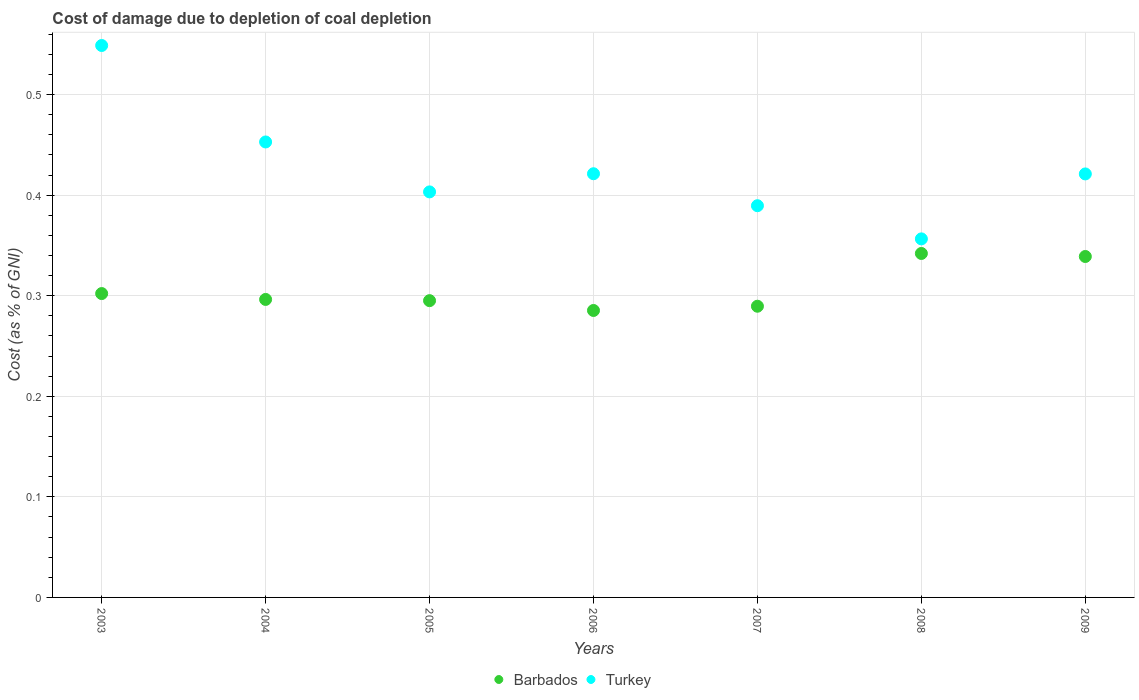How many different coloured dotlines are there?
Your answer should be compact. 2. What is the cost of damage caused due to coal depletion in Turkey in 2007?
Your response must be concise. 0.39. Across all years, what is the maximum cost of damage caused due to coal depletion in Barbados?
Offer a terse response. 0.34. Across all years, what is the minimum cost of damage caused due to coal depletion in Barbados?
Your answer should be compact. 0.29. In which year was the cost of damage caused due to coal depletion in Barbados maximum?
Your answer should be very brief. 2008. What is the total cost of damage caused due to coal depletion in Barbados in the graph?
Give a very brief answer. 2.15. What is the difference between the cost of damage caused due to coal depletion in Barbados in 2006 and that in 2007?
Offer a terse response. -0. What is the difference between the cost of damage caused due to coal depletion in Barbados in 2006 and the cost of damage caused due to coal depletion in Turkey in 2004?
Make the answer very short. -0.17. What is the average cost of damage caused due to coal depletion in Turkey per year?
Provide a succinct answer. 0.43. In the year 2009, what is the difference between the cost of damage caused due to coal depletion in Turkey and cost of damage caused due to coal depletion in Barbados?
Offer a terse response. 0.08. What is the ratio of the cost of damage caused due to coal depletion in Turkey in 2007 to that in 2008?
Your response must be concise. 1.09. Is the difference between the cost of damage caused due to coal depletion in Turkey in 2004 and 2006 greater than the difference between the cost of damage caused due to coal depletion in Barbados in 2004 and 2006?
Your answer should be very brief. Yes. What is the difference between the highest and the second highest cost of damage caused due to coal depletion in Turkey?
Provide a short and direct response. 0.1. What is the difference between the highest and the lowest cost of damage caused due to coal depletion in Barbados?
Make the answer very short. 0.06. Does the cost of damage caused due to coal depletion in Barbados monotonically increase over the years?
Ensure brevity in your answer.  No. Is the cost of damage caused due to coal depletion in Barbados strictly greater than the cost of damage caused due to coal depletion in Turkey over the years?
Keep it short and to the point. No. Is the cost of damage caused due to coal depletion in Barbados strictly less than the cost of damage caused due to coal depletion in Turkey over the years?
Give a very brief answer. Yes. How many years are there in the graph?
Provide a short and direct response. 7. What is the difference between two consecutive major ticks on the Y-axis?
Make the answer very short. 0.1. Are the values on the major ticks of Y-axis written in scientific E-notation?
Offer a terse response. No. Does the graph contain any zero values?
Provide a succinct answer. No. Where does the legend appear in the graph?
Offer a terse response. Bottom center. What is the title of the graph?
Ensure brevity in your answer.  Cost of damage due to depletion of coal depletion. Does "European Union" appear as one of the legend labels in the graph?
Your response must be concise. No. What is the label or title of the Y-axis?
Give a very brief answer. Cost (as % of GNI). What is the Cost (as % of GNI) in Barbados in 2003?
Keep it short and to the point. 0.3. What is the Cost (as % of GNI) in Turkey in 2003?
Offer a terse response. 0.55. What is the Cost (as % of GNI) in Barbados in 2004?
Offer a very short reply. 0.3. What is the Cost (as % of GNI) of Turkey in 2004?
Ensure brevity in your answer.  0.45. What is the Cost (as % of GNI) in Barbados in 2005?
Ensure brevity in your answer.  0.3. What is the Cost (as % of GNI) of Turkey in 2005?
Provide a succinct answer. 0.4. What is the Cost (as % of GNI) of Barbados in 2006?
Provide a succinct answer. 0.29. What is the Cost (as % of GNI) of Turkey in 2006?
Your answer should be very brief. 0.42. What is the Cost (as % of GNI) of Barbados in 2007?
Ensure brevity in your answer.  0.29. What is the Cost (as % of GNI) in Turkey in 2007?
Keep it short and to the point. 0.39. What is the Cost (as % of GNI) of Barbados in 2008?
Offer a very short reply. 0.34. What is the Cost (as % of GNI) in Turkey in 2008?
Offer a very short reply. 0.36. What is the Cost (as % of GNI) of Barbados in 2009?
Offer a terse response. 0.34. What is the Cost (as % of GNI) of Turkey in 2009?
Make the answer very short. 0.42. Across all years, what is the maximum Cost (as % of GNI) in Barbados?
Make the answer very short. 0.34. Across all years, what is the maximum Cost (as % of GNI) of Turkey?
Keep it short and to the point. 0.55. Across all years, what is the minimum Cost (as % of GNI) of Barbados?
Your answer should be very brief. 0.29. Across all years, what is the minimum Cost (as % of GNI) in Turkey?
Make the answer very short. 0.36. What is the total Cost (as % of GNI) in Barbados in the graph?
Your response must be concise. 2.15. What is the total Cost (as % of GNI) in Turkey in the graph?
Offer a very short reply. 2.99. What is the difference between the Cost (as % of GNI) in Barbados in 2003 and that in 2004?
Ensure brevity in your answer.  0.01. What is the difference between the Cost (as % of GNI) of Turkey in 2003 and that in 2004?
Make the answer very short. 0.1. What is the difference between the Cost (as % of GNI) of Barbados in 2003 and that in 2005?
Give a very brief answer. 0.01. What is the difference between the Cost (as % of GNI) of Turkey in 2003 and that in 2005?
Make the answer very short. 0.15. What is the difference between the Cost (as % of GNI) in Barbados in 2003 and that in 2006?
Keep it short and to the point. 0.02. What is the difference between the Cost (as % of GNI) in Turkey in 2003 and that in 2006?
Provide a short and direct response. 0.13. What is the difference between the Cost (as % of GNI) of Barbados in 2003 and that in 2007?
Give a very brief answer. 0.01. What is the difference between the Cost (as % of GNI) of Turkey in 2003 and that in 2007?
Your response must be concise. 0.16. What is the difference between the Cost (as % of GNI) of Barbados in 2003 and that in 2008?
Your answer should be compact. -0.04. What is the difference between the Cost (as % of GNI) of Turkey in 2003 and that in 2008?
Your answer should be very brief. 0.19. What is the difference between the Cost (as % of GNI) in Barbados in 2003 and that in 2009?
Your response must be concise. -0.04. What is the difference between the Cost (as % of GNI) of Turkey in 2003 and that in 2009?
Ensure brevity in your answer.  0.13. What is the difference between the Cost (as % of GNI) of Barbados in 2004 and that in 2005?
Provide a short and direct response. 0. What is the difference between the Cost (as % of GNI) in Turkey in 2004 and that in 2005?
Your answer should be compact. 0.05. What is the difference between the Cost (as % of GNI) of Barbados in 2004 and that in 2006?
Provide a short and direct response. 0.01. What is the difference between the Cost (as % of GNI) of Turkey in 2004 and that in 2006?
Make the answer very short. 0.03. What is the difference between the Cost (as % of GNI) in Barbados in 2004 and that in 2007?
Offer a terse response. 0.01. What is the difference between the Cost (as % of GNI) of Turkey in 2004 and that in 2007?
Provide a short and direct response. 0.06. What is the difference between the Cost (as % of GNI) of Barbados in 2004 and that in 2008?
Your answer should be compact. -0.05. What is the difference between the Cost (as % of GNI) of Turkey in 2004 and that in 2008?
Offer a terse response. 0.1. What is the difference between the Cost (as % of GNI) of Barbados in 2004 and that in 2009?
Your answer should be very brief. -0.04. What is the difference between the Cost (as % of GNI) in Turkey in 2004 and that in 2009?
Provide a short and direct response. 0.03. What is the difference between the Cost (as % of GNI) in Barbados in 2005 and that in 2006?
Your answer should be very brief. 0.01. What is the difference between the Cost (as % of GNI) in Turkey in 2005 and that in 2006?
Provide a succinct answer. -0.02. What is the difference between the Cost (as % of GNI) of Barbados in 2005 and that in 2007?
Make the answer very short. 0.01. What is the difference between the Cost (as % of GNI) of Turkey in 2005 and that in 2007?
Ensure brevity in your answer.  0.01. What is the difference between the Cost (as % of GNI) in Barbados in 2005 and that in 2008?
Provide a short and direct response. -0.05. What is the difference between the Cost (as % of GNI) of Turkey in 2005 and that in 2008?
Keep it short and to the point. 0.05. What is the difference between the Cost (as % of GNI) of Barbados in 2005 and that in 2009?
Offer a very short reply. -0.04. What is the difference between the Cost (as % of GNI) in Turkey in 2005 and that in 2009?
Offer a very short reply. -0.02. What is the difference between the Cost (as % of GNI) in Barbados in 2006 and that in 2007?
Your response must be concise. -0. What is the difference between the Cost (as % of GNI) in Turkey in 2006 and that in 2007?
Offer a terse response. 0.03. What is the difference between the Cost (as % of GNI) of Barbados in 2006 and that in 2008?
Ensure brevity in your answer.  -0.06. What is the difference between the Cost (as % of GNI) in Turkey in 2006 and that in 2008?
Provide a succinct answer. 0.06. What is the difference between the Cost (as % of GNI) of Barbados in 2006 and that in 2009?
Your answer should be compact. -0.05. What is the difference between the Cost (as % of GNI) of Barbados in 2007 and that in 2008?
Offer a terse response. -0.05. What is the difference between the Cost (as % of GNI) of Turkey in 2007 and that in 2008?
Keep it short and to the point. 0.03. What is the difference between the Cost (as % of GNI) in Barbados in 2007 and that in 2009?
Your answer should be very brief. -0.05. What is the difference between the Cost (as % of GNI) of Turkey in 2007 and that in 2009?
Offer a terse response. -0.03. What is the difference between the Cost (as % of GNI) of Barbados in 2008 and that in 2009?
Make the answer very short. 0. What is the difference between the Cost (as % of GNI) of Turkey in 2008 and that in 2009?
Make the answer very short. -0.06. What is the difference between the Cost (as % of GNI) of Barbados in 2003 and the Cost (as % of GNI) of Turkey in 2004?
Provide a short and direct response. -0.15. What is the difference between the Cost (as % of GNI) of Barbados in 2003 and the Cost (as % of GNI) of Turkey in 2005?
Give a very brief answer. -0.1. What is the difference between the Cost (as % of GNI) of Barbados in 2003 and the Cost (as % of GNI) of Turkey in 2006?
Provide a short and direct response. -0.12. What is the difference between the Cost (as % of GNI) in Barbados in 2003 and the Cost (as % of GNI) in Turkey in 2007?
Keep it short and to the point. -0.09. What is the difference between the Cost (as % of GNI) in Barbados in 2003 and the Cost (as % of GNI) in Turkey in 2008?
Give a very brief answer. -0.05. What is the difference between the Cost (as % of GNI) of Barbados in 2003 and the Cost (as % of GNI) of Turkey in 2009?
Make the answer very short. -0.12. What is the difference between the Cost (as % of GNI) in Barbados in 2004 and the Cost (as % of GNI) in Turkey in 2005?
Provide a short and direct response. -0.11. What is the difference between the Cost (as % of GNI) of Barbados in 2004 and the Cost (as % of GNI) of Turkey in 2006?
Give a very brief answer. -0.12. What is the difference between the Cost (as % of GNI) of Barbados in 2004 and the Cost (as % of GNI) of Turkey in 2007?
Your response must be concise. -0.09. What is the difference between the Cost (as % of GNI) of Barbados in 2004 and the Cost (as % of GNI) of Turkey in 2008?
Provide a short and direct response. -0.06. What is the difference between the Cost (as % of GNI) of Barbados in 2004 and the Cost (as % of GNI) of Turkey in 2009?
Your answer should be compact. -0.12. What is the difference between the Cost (as % of GNI) of Barbados in 2005 and the Cost (as % of GNI) of Turkey in 2006?
Give a very brief answer. -0.13. What is the difference between the Cost (as % of GNI) in Barbados in 2005 and the Cost (as % of GNI) in Turkey in 2007?
Ensure brevity in your answer.  -0.09. What is the difference between the Cost (as % of GNI) of Barbados in 2005 and the Cost (as % of GNI) of Turkey in 2008?
Your answer should be compact. -0.06. What is the difference between the Cost (as % of GNI) of Barbados in 2005 and the Cost (as % of GNI) of Turkey in 2009?
Offer a very short reply. -0.13. What is the difference between the Cost (as % of GNI) in Barbados in 2006 and the Cost (as % of GNI) in Turkey in 2007?
Keep it short and to the point. -0.1. What is the difference between the Cost (as % of GNI) in Barbados in 2006 and the Cost (as % of GNI) in Turkey in 2008?
Your response must be concise. -0.07. What is the difference between the Cost (as % of GNI) in Barbados in 2006 and the Cost (as % of GNI) in Turkey in 2009?
Keep it short and to the point. -0.14. What is the difference between the Cost (as % of GNI) in Barbados in 2007 and the Cost (as % of GNI) in Turkey in 2008?
Provide a short and direct response. -0.07. What is the difference between the Cost (as % of GNI) of Barbados in 2007 and the Cost (as % of GNI) of Turkey in 2009?
Your answer should be very brief. -0.13. What is the difference between the Cost (as % of GNI) of Barbados in 2008 and the Cost (as % of GNI) of Turkey in 2009?
Offer a very short reply. -0.08. What is the average Cost (as % of GNI) in Barbados per year?
Your answer should be compact. 0.31. What is the average Cost (as % of GNI) in Turkey per year?
Provide a short and direct response. 0.43. In the year 2003, what is the difference between the Cost (as % of GNI) in Barbados and Cost (as % of GNI) in Turkey?
Give a very brief answer. -0.25. In the year 2004, what is the difference between the Cost (as % of GNI) of Barbados and Cost (as % of GNI) of Turkey?
Your answer should be compact. -0.16. In the year 2005, what is the difference between the Cost (as % of GNI) of Barbados and Cost (as % of GNI) of Turkey?
Give a very brief answer. -0.11. In the year 2006, what is the difference between the Cost (as % of GNI) in Barbados and Cost (as % of GNI) in Turkey?
Your answer should be very brief. -0.14. In the year 2007, what is the difference between the Cost (as % of GNI) of Barbados and Cost (as % of GNI) of Turkey?
Provide a short and direct response. -0.1. In the year 2008, what is the difference between the Cost (as % of GNI) in Barbados and Cost (as % of GNI) in Turkey?
Your answer should be compact. -0.01. In the year 2009, what is the difference between the Cost (as % of GNI) in Barbados and Cost (as % of GNI) in Turkey?
Keep it short and to the point. -0.08. What is the ratio of the Cost (as % of GNI) in Barbados in 2003 to that in 2004?
Offer a very short reply. 1.02. What is the ratio of the Cost (as % of GNI) of Turkey in 2003 to that in 2004?
Keep it short and to the point. 1.21. What is the ratio of the Cost (as % of GNI) of Barbados in 2003 to that in 2005?
Make the answer very short. 1.02. What is the ratio of the Cost (as % of GNI) in Turkey in 2003 to that in 2005?
Your answer should be compact. 1.36. What is the ratio of the Cost (as % of GNI) of Barbados in 2003 to that in 2006?
Give a very brief answer. 1.06. What is the ratio of the Cost (as % of GNI) in Turkey in 2003 to that in 2006?
Provide a succinct answer. 1.3. What is the ratio of the Cost (as % of GNI) of Barbados in 2003 to that in 2007?
Give a very brief answer. 1.04. What is the ratio of the Cost (as % of GNI) in Turkey in 2003 to that in 2007?
Provide a short and direct response. 1.41. What is the ratio of the Cost (as % of GNI) of Barbados in 2003 to that in 2008?
Provide a succinct answer. 0.88. What is the ratio of the Cost (as % of GNI) of Turkey in 2003 to that in 2008?
Your answer should be very brief. 1.54. What is the ratio of the Cost (as % of GNI) of Barbados in 2003 to that in 2009?
Provide a short and direct response. 0.89. What is the ratio of the Cost (as % of GNI) of Turkey in 2003 to that in 2009?
Keep it short and to the point. 1.3. What is the ratio of the Cost (as % of GNI) of Barbados in 2004 to that in 2005?
Provide a short and direct response. 1. What is the ratio of the Cost (as % of GNI) in Turkey in 2004 to that in 2005?
Your answer should be very brief. 1.12. What is the ratio of the Cost (as % of GNI) of Barbados in 2004 to that in 2006?
Your answer should be very brief. 1.04. What is the ratio of the Cost (as % of GNI) in Turkey in 2004 to that in 2006?
Offer a terse response. 1.07. What is the ratio of the Cost (as % of GNI) of Barbados in 2004 to that in 2007?
Ensure brevity in your answer.  1.02. What is the ratio of the Cost (as % of GNI) in Turkey in 2004 to that in 2007?
Give a very brief answer. 1.16. What is the ratio of the Cost (as % of GNI) of Barbados in 2004 to that in 2008?
Your answer should be very brief. 0.87. What is the ratio of the Cost (as % of GNI) in Turkey in 2004 to that in 2008?
Provide a short and direct response. 1.27. What is the ratio of the Cost (as % of GNI) in Barbados in 2004 to that in 2009?
Your response must be concise. 0.87. What is the ratio of the Cost (as % of GNI) in Turkey in 2004 to that in 2009?
Your answer should be compact. 1.08. What is the ratio of the Cost (as % of GNI) in Barbados in 2005 to that in 2006?
Keep it short and to the point. 1.03. What is the ratio of the Cost (as % of GNI) of Turkey in 2005 to that in 2006?
Your answer should be compact. 0.96. What is the ratio of the Cost (as % of GNI) of Barbados in 2005 to that in 2007?
Your answer should be very brief. 1.02. What is the ratio of the Cost (as % of GNI) in Turkey in 2005 to that in 2007?
Make the answer very short. 1.04. What is the ratio of the Cost (as % of GNI) in Barbados in 2005 to that in 2008?
Give a very brief answer. 0.86. What is the ratio of the Cost (as % of GNI) in Turkey in 2005 to that in 2008?
Ensure brevity in your answer.  1.13. What is the ratio of the Cost (as % of GNI) of Barbados in 2005 to that in 2009?
Provide a short and direct response. 0.87. What is the ratio of the Cost (as % of GNI) in Turkey in 2005 to that in 2009?
Ensure brevity in your answer.  0.96. What is the ratio of the Cost (as % of GNI) in Barbados in 2006 to that in 2007?
Your answer should be compact. 0.99. What is the ratio of the Cost (as % of GNI) of Turkey in 2006 to that in 2007?
Provide a succinct answer. 1.08. What is the ratio of the Cost (as % of GNI) of Barbados in 2006 to that in 2008?
Your answer should be compact. 0.83. What is the ratio of the Cost (as % of GNI) in Turkey in 2006 to that in 2008?
Make the answer very short. 1.18. What is the ratio of the Cost (as % of GNI) in Barbados in 2006 to that in 2009?
Ensure brevity in your answer.  0.84. What is the ratio of the Cost (as % of GNI) of Turkey in 2006 to that in 2009?
Your answer should be compact. 1. What is the ratio of the Cost (as % of GNI) of Barbados in 2007 to that in 2008?
Your response must be concise. 0.85. What is the ratio of the Cost (as % of GNI) in Turkey in 2007 to that in 2008?
Provide a short and direct response. 1.09. What is the ratio of the Cost (as % of GNI) in Barbados in 2007 to that in 2009?
Keep it short and to the point. 0.85. What is the ratio of the Cost (as % of GNI) in Turkey in 2007 to that in 2009?
Provide a short and direct response. 0.93. What is the ratio of the Cost (as % of GNI) of Barbados in 2008 to that in 2009?
Keep it short and to the point. 1.01. What is the ratio of the Cost (as % of GNI) in Turkey in 2008 to that in 2009?
Provide a succinct answer. 0.85. What is the difference between the highest and the second highest Cost (as % of GNI) of Barbados?
Your answer should be very brief. 0. What is the difference between the highest and the second highest Cost (as % of GNI) in Turkey?
Your answer should be compact. 0.1. What is the difference between the highest and the lowest Cost (as % of GNI) of Barbados?
Make the answer very short. 0.06. What is the difference between the highest and the lowest Cost (as % of GNI) in Turkey?
Keep it short and to the point. 0.19. 